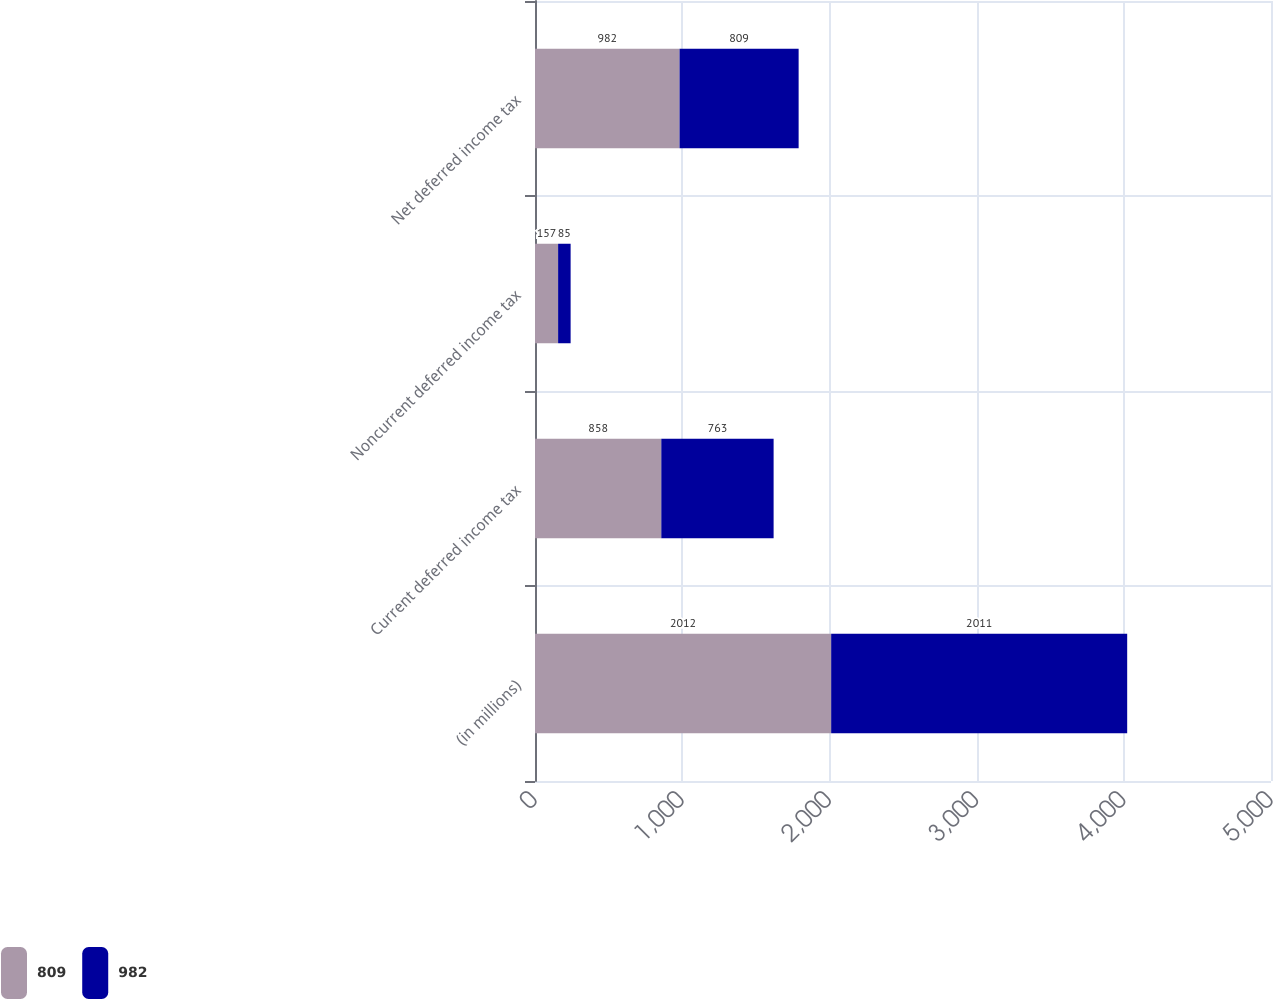Convert chart. <chart><loc_0><loc_0><loc_500><loc_500><stacked_bar_chart><ecel><fcel>(in millions)<fcel>Current deferred income tax<fcel>Noncurrent deferred income tax<fcel>Net deferred income tax<nl><fcel>809<fcel>2012<fcel>858<fcel>157<fcel>982<nl><fcel>982<fcel>2011<fcel>763<fcel>85<fcel>809<nl></chart> 